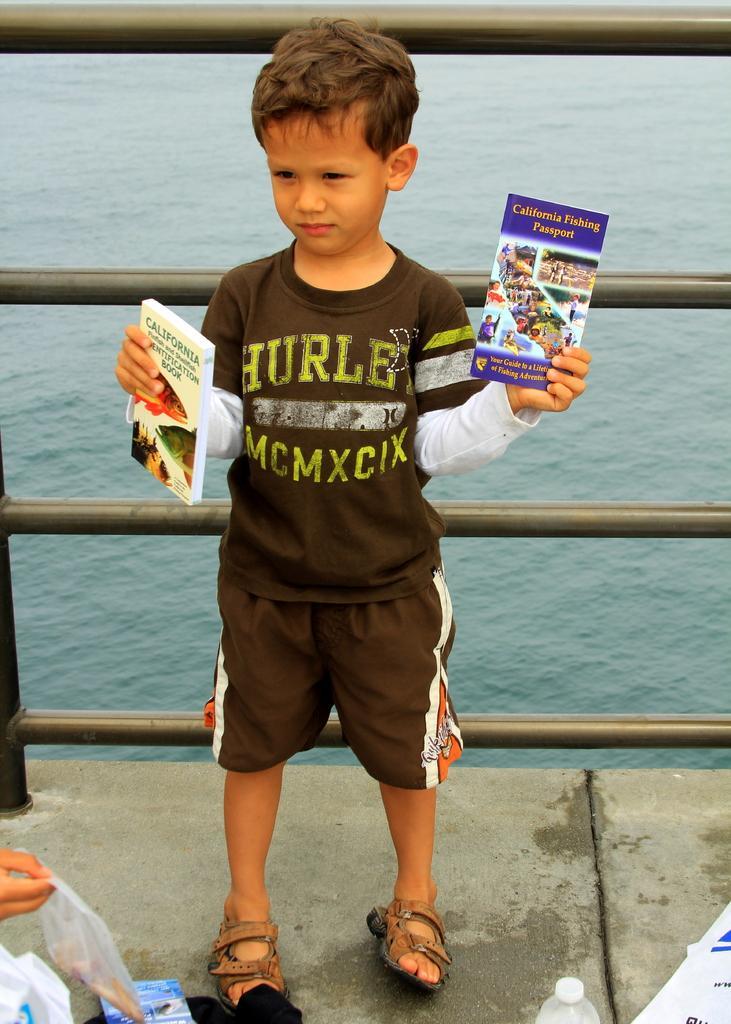Describe this image in one or two sentences. Here we can see a boy holding books with his hands. There are plastic covers and a bottle. In the background we can see water. 